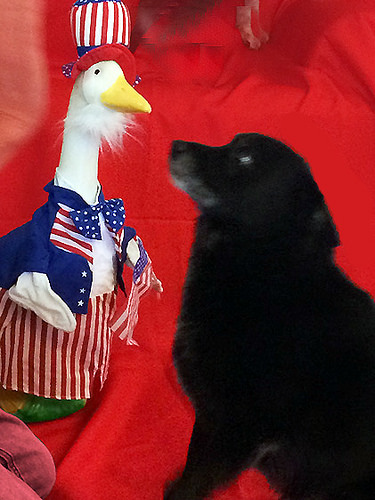<image>
Is there a dog to the left of the duck? No. The dog is not to the left of the duck. From this viewpoint, they have a different horizontal relationship. 